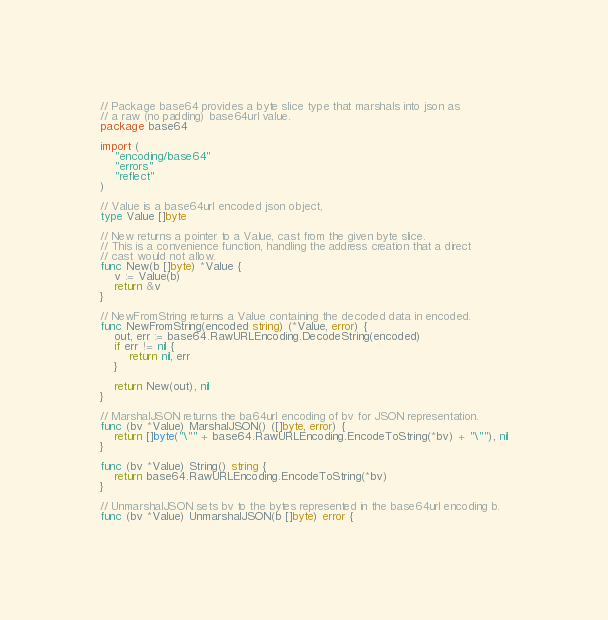<code> <loc_0><loc_0><loc_500><loc_500><_Go_>// Package base64 provides a byte slice type that marshals into json as
// a raw (no padding) base64url value.
package base64

import (
	"encoding/base64"
	"errors"
	"reflect"
)

// Value is a base64url encoded json object,
type Value []byte

// New returns a pointer to a Value, cast from the given byte slice.
// This is a convenience function, handling the address creation that a direct
// cast would not allow.
func New(b []byte) *Value {
	v := Value(b)
	return &v
}

// NewFromString returns a Value containing the decoded data in encoded.
func NewFromString(encoded string) (*Value, error) {
	out, err := base64.RawURLEncoding.DecodeString(encoded)
	if err != nil {
		return nil, err
	}

	return New(out), nil
}

// MarshalJSON returns the ba64url encoding of bv for JSON representation.
func (bv *Value) MarshalJSON() ([]byte, error) {
	return []byte("\"" + base64.RawURLEncoding.EncodeToString(*bv) + "\""), nil
}

func (bv *Value) String() string {
	return base64.RawURLEncoding.EncodeToString(*bv)
}

// UnmarshalJSON sets bv to the bytes represented in the base64url encoding b.
func (bv *Value) UnmarshalJSON(b []byte) error {</code> 